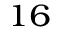Convert formula to latex. <formula><loc_0><loc_0><loc_500><loc_500>^ { 1 6 }</formula> 